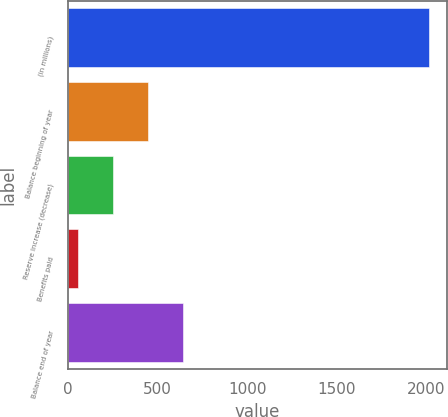Convert chart. <chart><loc_0><loc_0><loc_500><loc_500><bar_chart><fcel>(in millions)<fcel>Balance beginning of year<fcel>Reserve increase (decrease)<fcel>Benefits paid<fcel>Balance end of year<nl><fcel>2015<fcel>447.8<fcel>251.9<fcel>56<fcel>643.7<nl></chart> 